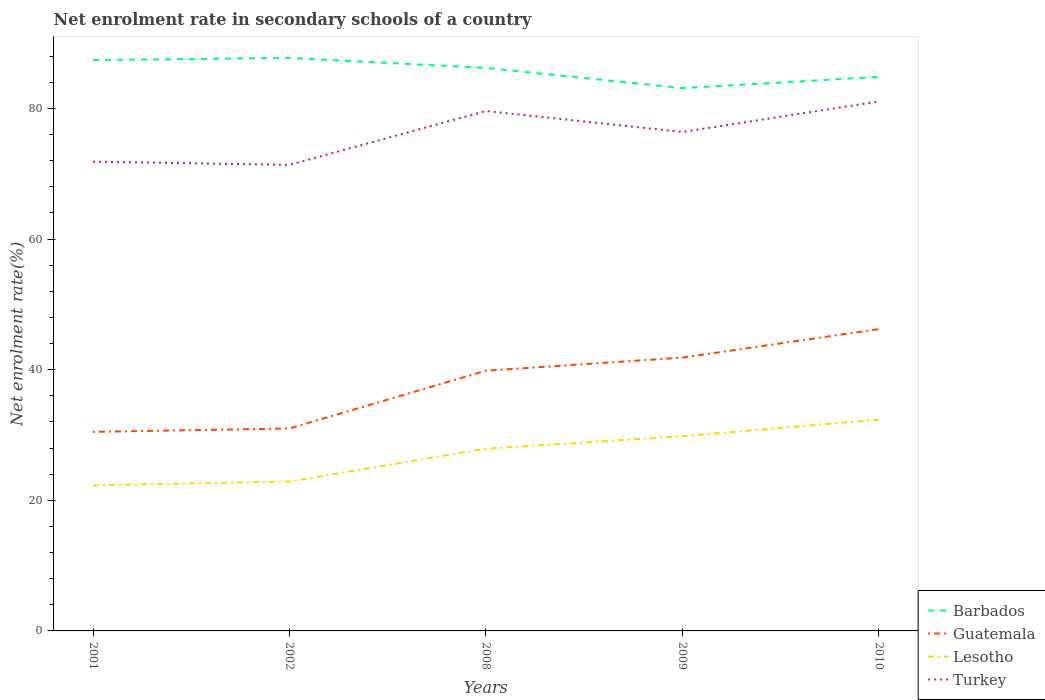Does the line corresponding to Guatemala intersect with the line corresponding to Turkey?
Ensure brevity in your answer.  No. Across all years, what is the maximum net enrolment rate in secondary schools in Turkey?
Ensure brevity in your answer.  71.37. What is the total net enrolment rate in secondary schools in Turkey in the graph?
Offer a terse response. -4.67. What is the difference between the highest and the second highest net enrolment rate in secondary schools in Guatemala?
Offer a very short reply. 15.74. What is the difference between the highest and the lowest net enrolment rate in secondary schools in Guatemala?
Provide a short and direct response. 3. Where does the legend appear in the graph?
Offer a very short reply. Bottom right. How many legend labels are there?
Offer a very short reply. 4. What is the title of the graph?
Make the answer very short. Net enrolment rate in secondary schools of a country. What is the label or title of the X-axis?
Make the answer very short. Years. What is the label or title of the Y-axis?
Provide a succinct answer. Net enrolment rate(%). What is the Net enrolment rate(%) in Barbados in 2001?
Provide a succinct answer. 87.42. What is the Net enrolment rate(%) in Guatemala in 2001?
Your response must be concise. 30.48. What is the Net enrolment rate(%) of Lesotho in 2001?
Ensure brevity in your answer.  22.3. What is the Net enrolment rate(%) of Turkey in 2001?
Your answer should be very brief. 71.86. What is the Net enrolment rate(%) of Barbados in 2002?
Keep it short and to the point. 87.74. What is the Net enrolment rate(%) of Guatemala in 2002?
Keep it short and to the point. 31. What is the Net enrolment rate(%) of Lesotho in 2002?
Offer a terse response. 22.88. What is the Net enrolment rate(%) of Turkey in 2002?
Offer a terse response. 71.37. What is the Net enrolment rate(%) in Barbados in 2008?
Make the answer very short. 86.22. What is the Net enrolment rate(%) of Guatemala in 2008?
Offer a very short reply. 39.85. What is the Net enrolment rate(%) in Lesotho in 2008?
Your answer should be compact. 27.91. What is the Net enrolment rate(%) of Turkey in 2008?
Make the answer very short. 79.62. What is the Net enrolment rate(%) in Barbados in 2009?
Ensure brevity in your answer.  83.12. What is the Net enrolment rate(%) in Guatemala in 2009?
Offer a terse response. 41.85. What is the Net enrolment rate(%) of Lesotho in 2009?
Provide a short and direct response. 29.81. What is the Net enrolment rate(%) in Turkey in 2009?
Make the answer very short. 76.41. What is the Net enrolment rate(%) in Barbados in 2010?
Your answer should be compact. 84.85. What is the Net enrolment rate(%) in Guatemala in 2010?
Keep it short and to the point. 46.22. What is the Net enrolment rate(%) of Lesotho in 2010?
Give a very brief answer. 32.36. What is the Net enrolment rate(%) in Turkey in 2010?
Provide a short and direct response. 81.08. Across all years, what is the maximum Net enrolment rate(%) of Barbados?
Offer a very short reply. 87.74. Across all years, what is the maximum Net enrolment rate(%) in Guatemala?
Provide a succinct answer. 46.22. Across all years, what is the maximum Net enrolment rate(%) of Lesotho?
Your answer should be very brief. 32.36. Across all years, what is the maximum Net enrolment rate(%) in Turkey?
Provide a succinct answer. 81.08. Across all years, what is the minimum Net enrolment rate(%) in Barbados?
Provide a succinct answer. 83.12. Across all years, what is the minimum Net enrolment rate(%) of Guatemala?
Your response must be concise. 30.48. Across all years, what is the minimum Net enrolment rate(%) of Lesotho?
Offer a terse response. 22.3. Across all years, what is the minimum Net enrolment rate(%) in Turkey?
Offer a very short reply. 71.37. What is the total Net enrolment rate(%) in Barbados in the graph?
Provide a succinct answer. 429.36. What is the total Net enrolment rate(%) in Guatemala in the graph?
Make the answer very short. 189.41. What is the total Net enrolment rate(%) in Lesotho in the graph?
Your response must be concise. 135.26. What is the total Net enrolment rate(%) of Turkey in the graph?
Offer a terse response. 380.34. What is the difference between the Net enrolment rate(%) of Barbados in 2001 and that in 2002?
Provide a succinct answer. -0.32. What is the difference between the Net enrolment rate(%) of Guatemala in 2001 and that in 2002?
Provide a succinct answer. -0.52. What is the difference between the Net enrolment rate(%) of Lesotho in 2001 and that in 2002?
Give a very brief answer. -0.58. What is the difference between the Net enrolment rate(%) of Turkey in 2001 and that in 2002?
Make the answer very short. 0.49. What is the difference between the Net enrolment rate(%) of Barbados in 2001 and that in 2008?
Ensure brevity in your answer.  1.2. What is the difference between the Net enrolment rate(%) in Guatemala in 2001 and that in 2008?
Ensure brevity in your answer.  -9.37. What is the difference between the Net enrolment rate(%) of Lesotho in 2001 and that in 2008?
Offer a very short reply. -5.61. What is the difference between the Net enrolment rate(%) of Turkey in 2001 and that in 2008?
Give a very brief answer. -7.76. What is the difference between the Net enrolment rate(%) in Barbados in 2001 and that in 2009?
Provide a succinct answer. 4.3. What is the difference between the Net enrolment rate(%) of Guatemala in 2001 and that in 2009?
Make the answer very short. -11.37. What is the difference between the Net enrolment rate(%) of Lesotho in 2001 and that in 2009?
Your answer should be compact. -7.52. What is the difference between the Net enrolment rate(%) of Turkey in 2001 and that in 2009?
Keep it short and to the point. -4.54. What is the difference between the Net enrolment rate(%) in Barbados in 2001 and that in 2010?
Give a very brief answer. 2.58. What is the difference between the Net enrolment rate(%) in Guatemala in 2001 and that in 2010?
Your response must be concise. -15.74. What is the difference between the Net enrolment rate(%) in Lesotho in 2001 and that in 2010?
Give a very brief answer. -10.07. What is the difference between the Net enrolment rate(%) in Turkey in 2001 and that in 2010?
Provide a short and direct response. -9.22. What is the difference between the Net enrolment rate(%) in Barbados in 2002 and that in 2008?
Provide a short and direct response. 1.52. What is the difference between the Net enrolment rate(%) of Guatemala in 2002 and that in 2008?
Give a very brief answer. -8.85. What is the difference between the Net enrolment rate(%) of Lesotho in 2002 and that in 2008?
Ensure brevity in your answer.  -5.03. What is the difference between the Net enrolment rate(%) of Turkey in 2002 and that in 2008?
Offer a terse response. -8.25. What is the difference between the Net enrolment rate(%) of Barbados in 2002 and that in 2009?
Offer a very short reply. 4.62. What is the difference between the Net enrolment rate(%) of Guatemala in 2002 and that in 2009?
Offer a very short reply. -10.85. What is the difference between the Net enrolment rate(%) in Lesotho in 2002 and that in 2009?
Your answer should be compact. -6.93. What is the difference between the Net enrolment rate(%) of Turkey in 2002 and that in 2009?
Give a very brief answer. -5.03. What is the difference between the Net enrolment rate(%) in Barbados in 2002 and that in 2010?
Your answer should be compact. 2.9. What is the difference between the Net enrolment rate(%) of Guatemala in 2002 and that in 2010?
Ensure brevity in your answer.  -15.22. What is the difference between the Net enrolment rate(%) in Lesotho in 2002 and that in 2010?
Provide a short and direct response. -9.48. What is the difference between the Net enrolment rate(%) of Turkey in 2002 and that in 2010?
Make the answer very short. -9.71. What is the difference between the Net enrolment rate(%) of Barbados in 2008 and that in 2009?
Your response must be concise. 3.1. What is the difference between the Net enrolment rate(%) in Guatemala in 2008 and that in 2009?
Provide a succinct answer. -2. What is the difference between the Net enrolment rate(%) of Lesotho in 2008 and that in 2009?
Your answer should be compact. -1.9. What is the difference between the Net enrolment rate(%) of Turkey in 2008 and that in 2009?
Your answer should be very brief. 3.22. What is the difference between the Net enrolment rate(%) of Barbados in 2008 and that in 2010?
Offer a terse response. 1.38. What is the difference between the Net enrolment rate(%) of Guatemala in 2008 and that in 2010?
Provide a short and direct response. -6.37. What is the difference between the Net enrolment rate(%) in Lesotho in 2008 and that in 2010?
Keep it short and to the point. -4.45. What is the difference between the Net enrolment rate(%) in Turkey in 2008 and that in 2010?
Provide a succinct answer. -1.46. What is the difference between the Net enrolment rate(%) of Barbados in 2009 and that in 2010?
Ensure brevity in your answer.  -1.72. What is the difference between the Net enrolment rate(%) in Guatemala in 2009 and that in 2010?
Offer a very short reply. -4.36. What is the difference between the Net enrolment rate(%) of Lesotho in 2009 and that in 2010?
Provide a succinct answer. -2.55. What is the difference between the Net enrolment rate(%) of Turkey in 2009 and that in 2010?
Offer a terse response. -4.67. What is the difference between the Net enrolment rate(%) of Barbados in 2001 and the Net enrolment rate(%) of Guatemala in 2002?
Your answer should be compact. 56.42. What is the difference between the Net enrolment rate(%) in Barbados in 2001 and the Net enrolment rate(%) in Lesotho in 2002?
Give a very brief answer. 64.54. What is the difference between the Net enrolment rate(%) of Barbados in 2001 and the Net enrolment rate(%) of Turkey in 2002?
Your answer should be compact. 16.05. What is the difference between the Net enrolment rate(%) of Guatemala in 2001 and the Net enrolment rate(%) of Lesotho in 2002?
Offer a terse response. 7.6. What is the difference between the Net enrolment rate(%) in Guatemala in 2001 and the Net enrolment rate(%) in Turkey in 2002?
Offer a very short reply. -40.89. What is the difference between the Net enrolment rate(%) of Lesotho in 2001 and the Net enrolment rate(%) of Turkey in 2002?
Provide a short and direct response. -49.08. What is the difference between the Net enrolment rate(%) in Barbados in 2001 and the Net enrolment rate(%) in Guatemala in 2008?
Offer a terse response. 47.57. What is the difference between the Net enrolment rate(%) in Barbados in 2001 and the Net enrolment rate(%) in Lesotho in 2008?
Offer a very short reply. 59.52. What is the difference between the Net enrolment rate(%) in Barbados in 2001 and the Net enrolment rate(%) in Turkey in 2008?
Your answer should be very brief. 7.8. What is the difference between the Net enrolment rate(%) in Guatemala in 2001 and the Net enrolment rate(%) in Lesotho in 2008?
Your answer should be very brief. 2.58. What is the difference between the Net enrolment rate(%) in Guatemala in 2001 and the Net enrolment rate(%) in Turkey in 2008?
Offer a very short reply. -49.14. What is the difference between the Net enrolment rate(%) in Lesotho in 2001 and the Net enrolment rate(%) in Turkey in 2008?
Give a very brief answer. -57.33. What is the difference between the Net enrolment rate(%) of Barbados in 2001 and the Net enrolment rate(%) of Guatemala in 2009?
Offer a terse response. 45.57. What is the difference between the Net enrolment rate(%) in Barbados in 2001 and the Net enrolment rate(%) in Lesotho in 2009?
Your response must be concise. 57.61. What is the difference between the Net enrolment rate(%) in Barbados in 2001 and the Net enrolment rate(%) in Turkey in 2009?
Offer a very short reply. 11.02. What is the difference between the Net enrolment rate(%) of Guatemala in 2001 and the Net enrolment rate(%) of Lesotho in 2009?
Offer a terse response. 0.67. What is the difference between the Net enrolment rate(%) in Guatemala in 2001 and the Net enrolment rate(%) in Turkey in 2009?
Provide a short and direct response. -45.92. What is the difference between the Net enrolment rate(%) of Lesotho in 2001 and the Net enrolment rate(%) of Turkey in 2009?
Keep it short and to the point. -54.11. What is the difference between the Net enrolment rate(%) in Barbados in 2001 and the Net enrolment rate(%) in Guatemala in 2010?
Your answer should be compact. 41.21. What is the difference between the Net enrolment rate(%) in Barbados in 2001 and the Net enrolment rate(%) in Lesotho in 2010?
Give a very brief answer. 55.06. What is the difference between the Net enrolment rate(%) in Barbados in 2001 and the Net enrolment rate(%) in Turkey in 2010?
Give a very brief answer. 6.34. What is the difference between the Net enrolment rate(%) in Guatemala in 2001 and the Net enrolment rate(%) in Lesotho in 2010?
Give a very brief answer. -1.88. What is the difference between the Net enrolment rate(%) of Guatemala in 2001 and the Net enrolment rate(%) of Turkey in 2010?
Your answer should be compact. -50.6. What is the difference between the Net enrolment rate(%) of Lesotho in 2001 and the Net enrolment rate(%) of Turkey in 2010?
Your answer should be very brief. -58.78. What is the difference between the Net enrolment rate(%) in Barbados in 2002 and the Net enrolment rate(%) in Guatemala in 2008?
Your answer should be compact. 47.89. What is the difference between the Net enrolment rate(%) of Barbados in 2002 and the Net enrolment rate(%) of Lesotho in 2008?
Keep it short and to the point. 59.84. What is the difference between the Net enrolment rate(%) in Barbados in 2002 and the Net enrolment rate(%) in Turkey in 2008?
Keep it short and to the point. 8.12. What is the difference between the Net enrolment rate(%) in Guatemala in 2002 and the Net enrolment rate(%) in Lesotho in 2008?
Offer a very short reply. 3.1. What is the difference between the Net enrolment rate(%) of Guatemala in 2002 and the Net enrolment rate(%) of Turkey in 2008?
Make the answer very short. -48.62. What is the difference between the Net enrolment rate(%) in Lesotho in 2002 and the Net enrolment rate(%) in Turkey in 2008?
Offer a terse response. -56.74. What is the difference between the Net enrolment rate(%) in Barbados in 2002 and the Net enrolment rate(%) in Guatemala in 2009?
Provide a succinct answer. 45.89. What is the difference between the Net enrolment rate(%) of Barbados in 2002 and the Net enrolment rate(%) of Lesotho in 2009?
Keep it short and to the point. 57.93. What is the difference between the Net enrolment rate(%) of Barbados in 2002 and the Net enrolment rate(%) of Turkey in 2009?
Make the answer very short. 11.34. What is the difference between the Net enrolment rate(%) of Guatemala in 2002 and the Net enrolment rate(%) of Lesotho in 2009?
Ensure brevity in your answer.  1.19. What is the difference between the Net enrolment rate(%) in Guatemala in 2002 and the Net enrolment rate(%) in Turkey in 2009?
Offer a very short reply. -45.4. What is the difference between the Net enrolment rate(%) of Lesotho in 2002 and the Net enrolment rate(%) of Turkey in 2009?
Provide a short and direct response. -53.53. What is the difference between the Net enrolment rate(%) of Barbados in 2002 and the Net enrolment rate(%) of Guatemala in 2010?
Your answer should be compact. 41.53. What is the difference between the Net enrolment rate(%) of Barbados in 2002 and the Net enrolment rate(%) of Lesotho in 2010?
Your answer should be very brief. 55.38. What is the difference between the Net enrolment rate(%) in Barbados in 2002 and the Net enrolment rate(%) in Turkey in 2010?
Offer a terse response. 6.66. What is the difference between the Net enrolment rate(%) of Guatemala in 2002 and the Net enrolment rate(%) of Lesotho in 2010?
Give a very brief answer. -1.36. What is the difference between the Net enrolment rate(%) of Guatemala in 2002 and the Net enrolment rate(%) of Turkey in 2010?
Provide a short and direct response. -50.08. What is the difference between the Net enrolment rate(%) of Lesotho in 2002 and the Net enrolment rate(%) of Turkey in 2010?
Your response must be concise. -58.2. What is the difference between the Net enrolment rate(%) in Barbados in 2008 and the Net enrolment rate(%) in Guatemala in 2009?
Give a very brief answer. 44.37. What is the difference between the Net enrolment rate(%) in Barbados in 2008 and the Net enrolment rate(%) in Lesotho in 2009?
Offer a terse response. 56.41. What is the difference between the Net enrolment rate(%) in Barbados in 2008 and the Net enrolment rate(%) in Turkey in 2009?
Your answer should be compact. 9.82. What is the difference between the Net enrolment rate(%) in Guatemala in 2008 and the Net enrolment rate(%) in Lesotho in 2009?
Your answer should be compact. 10.04. What is the difference between the Net enrolment rate(%) of Guatemala in 2008 and the Net enrolment rate(%) of Turkey in 2009?
Give a very brief answer. -36.56. What is the difference between the Net enrolment rate(%) in Lesotho in 2008 and the Net enrolment rate(%) in Turkey in 2009?
Offer a very short reply. -48.5. What is the difference between the Net enrolment rate(%) of Barbados in 2008 and the Net enrolment rate(%) of Guatemala in 2010?
Your answer should be very brief. 40. What is the difference between the Net enrolment rate(%) of Barbados in 2008 and the Net enrolment rate(%) of Lesotho in 2010?
Your answer should be compact. 53.86. What is the difference between the Net enrolment rate(%) in Barbados in 2008 and the Net enrolment rate(%) in Turkey in 2010?
Provide a short and direct response. 5.14. What is the difference between the Net enrolment rate(%) in Guatemala in 2008 and the Net enrolment rate(%) in Lesotho in 2010?
Give a very brief answer. 7.49. What is the difference between the Net enrolment rate(%) in Guatemala in 2008 and the Net enrolment rate(%) in Turkey in 2010?
Your response must be concise. -41.23. What is the difference between the Net enrolment rate(%) in Lesotho in 2008 and the Net enrolment rate(%) in Turkey in 2010?
Offer a terse response. -53.17. What is the difference between the Net enrolment rate(%) of Barbados in 2009 and the Net enrolment rate(%) of Guatemala in 2010?
Give a very brief answer. 36.91. What is the difference between the Net enrolment rate(%) of Barbados in 2009 and the Net enrolment rate(%) of Lesotho in 2010?
Give a very brief answer. 50.76. What is the difference between the Net enrolment rate(%) in Barbados in 2009 and the Net enrolment rate(%) in Turkey in 2010?
Your answer should be very brief. 2.04. What is the difference between the Net enrolment rate(%) of Guatemala in 2009 and the Net enrolment rate(%) of Lesotho in 2010?
Ensure brevity in your answer.  9.49. What is the difference between the Net enrolment rate(%) in Guatemala in 2009 and the Net enrolment rate(%) in Turkey in 2010?
Make the answer very short. -39.23. What is the difference between the Net enrolment rate(%) of Lesotho in 2009 and the Net enrolment rate(%) of Turkey in 2010?
Keep it short and to the point. -51.27. What is the average Net enrolment rate(%) of Barbados per year?
Provide a succinct answer. 85.87. What is the average Net enrolment rate(%) of Guatemala per year?
Keep it short and to the point. 37.88. What is the average Net enrolment rate(%) in Lesotho per year?
Your answer should be compact. 27.05. What is the average Net enrolment rate(%) of Turkey per year?
Provide a succinct answer. 76.07. In the year 2001, what is the difference between the Net enrolment rate(%) of Barbados and Net enrolment rate(%) of Guatemala?
Offer a terse response. 56.94. In the year 2001, what is the difference between the Net enrolment rate(%) in Barbados and Net enrolment rate(%) in Lesotho?
Your answer should be compact. 65.13. In the year 2001, what is the difference between the Net enrolment rate(%) in Barbados and Net enrolment rate(%) in Turkey?
Your response must be concise. 15.56. In the year 2001, what is the difference between the Net enrolment rate(%) in Guatemala and Net enrolment rate(%) in Lesotho?
Keep it short and to the point. 8.19. In the year 2001, what is the difference between the Net enrolment rate(%) in Guatemala and Net enrolment rate(%) in Turkey?
Provide a succinct answer. -41.38. In the year 2001, what is the difference between the Net enrolment rate(%) in Lesotho and Net enrolment rate(%) in Turkey?
Ensure brevity in your answer.  -49.57. In the year 2002, what is the difference between the Net enrolment rate(%) of Barbados and Net enrolment rate(%) of Guatemala?
Give a very brief answer. 56.74. In the year 2002, what is the difference between the Net enrolment rate(%) in Barbados and Net enrolment rate(%) in Lesotho?
Your answer should be very brief. 64.86. In the year 2002, what is the difference between the Net enrolment rate(%) in Barbados and Net enrolment rate(%) in Turkey?
Make the answer very short. 16.37. In the year 2002, what is the difference between the Net enrolment rate(%) of Guatemala and Net enrolment rate(%) of Lesotho?
Keep it short and to the point. 8.12. In the year 2002, what is the difference between the Net enrolment rate(%) of Guatemala and Net enrolment rate(%) of Turkey?
Ensure brevity in your answer.  -40.37. In the year 2002, what is the difference between the Net enrolment rate(%) in Lesotho and Net enrolment rate(%) in Turkey?
Make the answer very short. -48.49. In the year 2008, what is the difference between the Net enrolment rate(%) in Barbados and Net enrolment rate(%) in Guatemala?
Your response must be concise. 46.37. In the year 2008, what is the difference between the Net enrolment rate(%) of Barbados and Net enrolment rate(%) of Lesotho?
Your answer should be very brief. 58.32. In the year 2008, what is the difference between the Net enrolment rate(%) in Barbados and Net enrolment rate(%) in Turkey?
Your answer should be compact. 6.6. In the year 2008, what is the difference between the Net enrolment rate(%) in Guatemala and Net enrolment rate(%) in Lesotho?
Make the answer very short. 11.94. In the year 2008, what is the difference between the Net enrolment rate(%) in Guatemala and Net enrolment rate(%) in Turkey?
Your answer should be compact. -39.77. In the year 2008, what is the difference between the Net enrolment rate(%) of Lesotho and Net enrolment rate(%) of Turkey?
Your answer should be compact. -51.72. In the year 2009, what is the difference between the Net enrolment rate(%) in Barbados and Net enrolment rate(%) in Guatemala?
Provide a succinct answer. 41.27. In the year 2009, what is the difference between the Net enrolment rate(%) of Barbados and Net enrolment rate(%) of Lesotho?
Keep it short and to the point. 53.31. In the year 2009, what is the difference between the Net enrolment rate(%) in Barbados and Net enrolment rate(%) in Turkey?
Your answer should be compact. 6.72. In the year 2009, what is the difference between the Net enrolment rate(%) of Guatemala and Net enrolment rate(%) of Lesotho?
Provide a succinct answer. 12.04. In the year 2009, what is the difference between the Net enrolment rate(%) of Guatemala and Net enrolment rate(%) of Turkey?
Your response must be concise. -34.55. In the year 2009, what is the difference between the Net enrolment rate(%) of Lesotho and Net enrolment rate(%) of Turkey?
Ensure brevity in your answer.  -46.59. In the year 2010, what is the difference between the Net enrolment rate(%) of Barbados and Net enrolment rate(%) of Guatemala?
Your response must be concise. 38.63. In the year 2010, what is the difference between the Net enrolment rate(%) in Barbados and Net enrolment rate(%) in Lesotho?
Ensure brevity in your answer.  52.48. In the year 2010, what is the difference between the Net enrolment rate(%) in Barbados and Net enrolment rate(%) in Turkey?
Provide a succinct answer. 3.77. In the year 2010, what is the difference between the Net enrolment rate(%) of Guatemala and Net enrolment rate(%) of Lesotho?
Give a very brief answer. 13.86. In the year 2010, what is the difference between the Net enrolment rate(%) in Guatemala and Net enrolment rate(%) in Turkey?
Offer a very short reply. -34.86. In the year 2010, what is the difference between the Net enrolment rate(%) in Lesotho and Net enrolment rate(%) in Turkey?
Ensure brevity in your answer.  -48.72. What is the ratio of the Net enrolment rate(%) of Barbados in 2001 to that in 2002?
Offer a terse response. 1. What is the ratio of the Net enrolment rate(%) in Guatemala in 2001 to that in 2002?
Your answer should be compact. 0.98. What is the ratio of the Net enrolment rate(%) in Lesotho in 2001 to that in 2002?
Your answer should be very brief. 0.97. What is the ratio of the Net enrolment rate(%) of Turkey in 2001 to that in 2002?
Offer a terse response. 1.01. What is the ratio of the Net enrolment rate(%) of Barbados in 2001 to that in 2008?
Offer a very short reply. 1.01. What is the ratio of the Net enrolment rate(%) in Guatemala in 2001 to that in 2008?
Provide a short and direct response. 0.76. What is the ratio of the Net enrolment rate(%) of Lesotho in 2001 to that in 2008?
Your answer should be very brief. 0.8. What is the ratio of the Net enrolment rate(%) in Turkey in 2001 to that in 2008?
Give a very brief answer. 0.9. What is the ratio of the Net enrolment rate(%) of Barbados in 2001 to that in 2009?
Your answer should be very brief. 1.05. What is the ratio of the Net enrolment rate(%) in Guatemala in 2001 to that in 2009?
Provide a short and direct response. 0.73. What is the ratio of the Net enrolment rate(%) in Lesotho in 2001 to that in 2009?
Ensure brevity in your answer.  0.75. What is the ratio of the Net enrolment rate(%) of Turkey in 2001 to that in 2009?
Offer a very short reply. 0.94. What is the ratio of the Net enrolment rate(%) in Barbados in 2001 to that in 2010?
Make the answer very short. 1.03. What is the ratio of the Net enrolment rate(%) in Guatemala in 2001 to that in 2010?
Offer a very short reply. 0.66. What is the ratio of the Net enrolment rate(%) in Lesotho in 2001 to that in 2010?
Ensure brevity in your answer.  0.69. What is the ratio of the Net enrolment rate(%) in Turkey in 2001 to that in 2010?
Offer a very short reply. 0.89. What is the ratio of the Net enrolment rate(%) of Barbados in 2002 to that in 2008?
Provide a short and direct response. 1.02. What is the ratio of the Net enrolment rate(%) of Guatemala in 2002 to that in 2008?
Provide a succinct answer. 0.78. What is the ratio of the Net enrolment rate(%) in Lesotho in 2002 to that in 2008?
Your answer should be compact. 0.82. What is the ratio of the Net enrolment rate(%) of Turkey in 2002 to that in 2008?
Offer a terse response. 0.9. What is the ratio of the Net enrolment rate(%) in Barbados in 2002 to that in 2009?
Your answer should be compact. 1.06. What is the ratio of the Net enrolment rate(%) in Guatemala in 2002 to that in 2009?
Provide a succinct answer. 0.74. What is the ratio of the Net enrolment rate(%) in Lesotho in 2002 to that in 2009?
Offer a terse response. 0.77. What is the ratio of the Net enrolment rate(%) of Turkey in 2002 to that in 2009?
Make the answer very short. 0.93. What is the ratio of the Net enrolment rate(%) in Barbados in 2002 to that in 2010?
Offer a very short reply. 1.03. What is the ratio of the Net enrolment rate(%) in Guatemala in 2002 to that in 2010?
Offer a terse response. 0.67. What is the ratio of the Net enrolment rate(%) in Lesotho in 2002 to that in 2010?
Offer a terse response. 0.71. What is the ratio of the Net enrolment rate(%) of Turkey in 2002 to that in 2010?
Give a very brief answer. 0.88. What is the ratio of the Net enrolment rate(%) in Barbados in 2008 to that in 2009?
Offer a very short reply. 1.04. What is the ratio of the Net enrolment rate(%) of Guatemala in 2008 to that in 2009?
Keep it short and to the point. 0.95. What is the ratio of the Net enrolment rate(%) in Lesotho in 2008 to that in 2009?
Your response must be concise. 0.94. What is the ratio of the Net enrolment rate(%) of Turkey in 2008 to that in 2009?
Offer a very short reply. 1.04. What is the ratio of the Net enrolment rate(%) in Barbados in 2008 to that in 2010?
Offer a very short reply. 1.02. What is the ratio of the Net enrolment rate(%) in Guatemala in 2008 to that in 2010?
Provide a succinct answer. 0.86. What is the ratio of the Net enrolment rate(%) of Lesotho in 2008 to that in 2010?
Provide a short and direct response. 0.86. What is the ratio of the Net enrolment rate(%) in Turkey in 2008 to that in 2010?
Your answer should be very brief. 0.98. What is the ratio of the Net enrolment rate(%) of Barbados in 2009 to that in 2010?
Offer a very short reply. 0.98. What is the ratio of the Net enrolment rate(%) in Guatemala in 2009 to that in 2010?
Offer a very short reply. 0.91. What is the ratio of the Net enrolment rate(%) of Lesotho in 2009 to that in 2010?
Make the answer very short. 0.92. What is the ratio of the Net enrolment rate(%) in Turkey in 2009 to that in 2010?
Offer a terse response. 0.94. What is the difference between the highest and the second highest Net enrolment rate(%) in Barbados?
Your response must be concise. 0.32. What is the difference between the highest and the second highest Net enrolment rate(%) in Guatemala?
Your answer should be very brief. 4.36. What is the difference between the highest and the second highest Net enrolment rate(%) of Lesotho?
Your answer should be very brief. 2.55. What is the difference between the highest and the second highest Net enrolment rate(%) of Turkey?
Your answer should be compact. 1.46. What is the difference between the highest and the lowest Net enrolment rate(%) of Barbados?
Offer a very short reply. 4.62. What is the difference between the highest and the lowest Net enrolment rate(%) of Guatemala?
Your answer should be compact. 15.74. What is the difference between the highest and the lowest Net enrolment rate(%) of Lesotho?
Provide a succinct answer. 10.07. What is the difference between the highest and the lowest Net enrolment rate(%) in Turkey?
Your answer should be very brief. 9.71. 